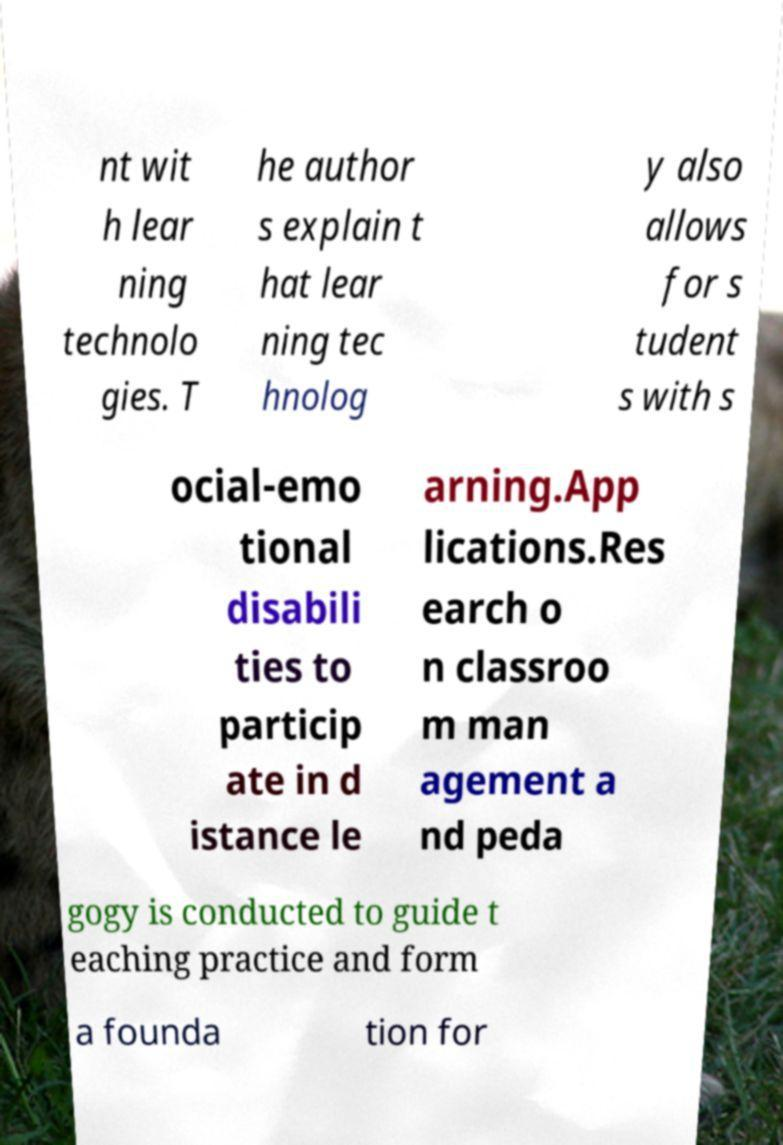Please identify and transcribe the text found in this image. nt wit h lear ning technolo gies. T he author s explain t hat lear ning tec hnolog y also allows for s tudent s with s ocial-emo tional disabili ties to particip ate in d istance le arning.App lications.Res earch o n classroo m man agement a nd peda gogy is conducted to guide t eaching practice and form a founda tion for 